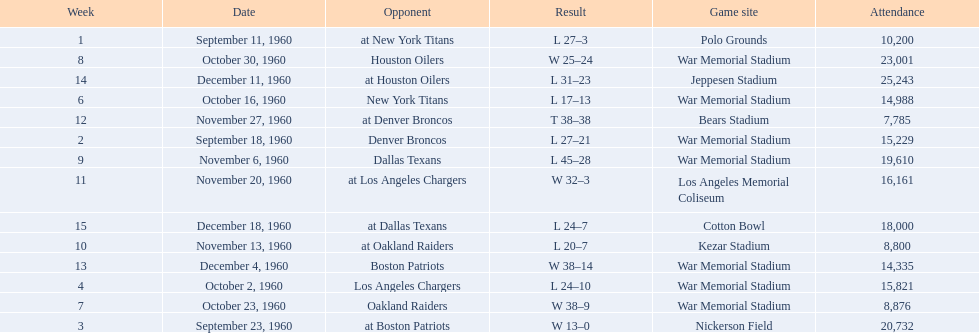Who was the only opponent they played which resulted in a tie game? Denver Broncos. 